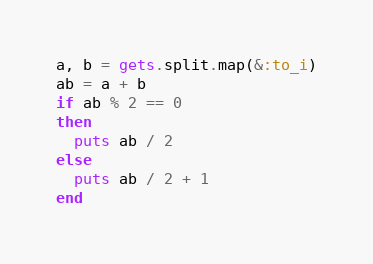Convert code to text. <code><loc_0><loc_0><loc_500><loc_500><_Ruby_>a, b = gets.split.map(&:to_i)
ab = a + b
if ab % 2 == 0
then
  puts ab / 2
else
  puts ab / 2 + 1
end</code> 